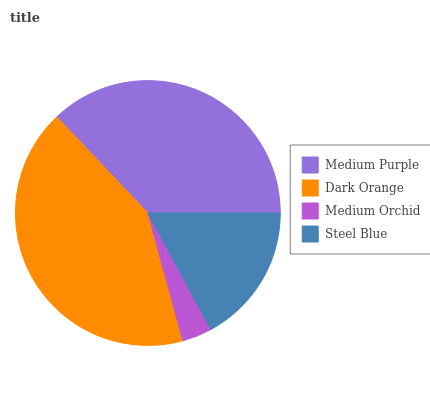Is Medium Orchid the minimum?
Answer yes or no. Yes. Is Dark Orange the maximum?
Answer yes or no. Yes. Is Dark Orange the minimum?
Answer yes or no. No. Is Medium Orchid the maximum?
Answer yes or no. No. Is Dark Orange greater than Medium Orchid?
Answer yes or no. Yes. Is Medium Orchid less than Dark Orange?
Answer yes or no. Yes. Is Medium Orchid greater than Dark Orange?
Answer yes or no. No. Is Dark Orange less than Medium Orchid?
Answer yes or no. No. Is Medium Purple the high median?
Answer yes or no. Yes. Is Steel Blue the low median?
Answer yes or no. Yes. Is Steel Blue the high median?
Answer yes or no. No. Is Medium Purple the low median?
Answer yes or no. No. 